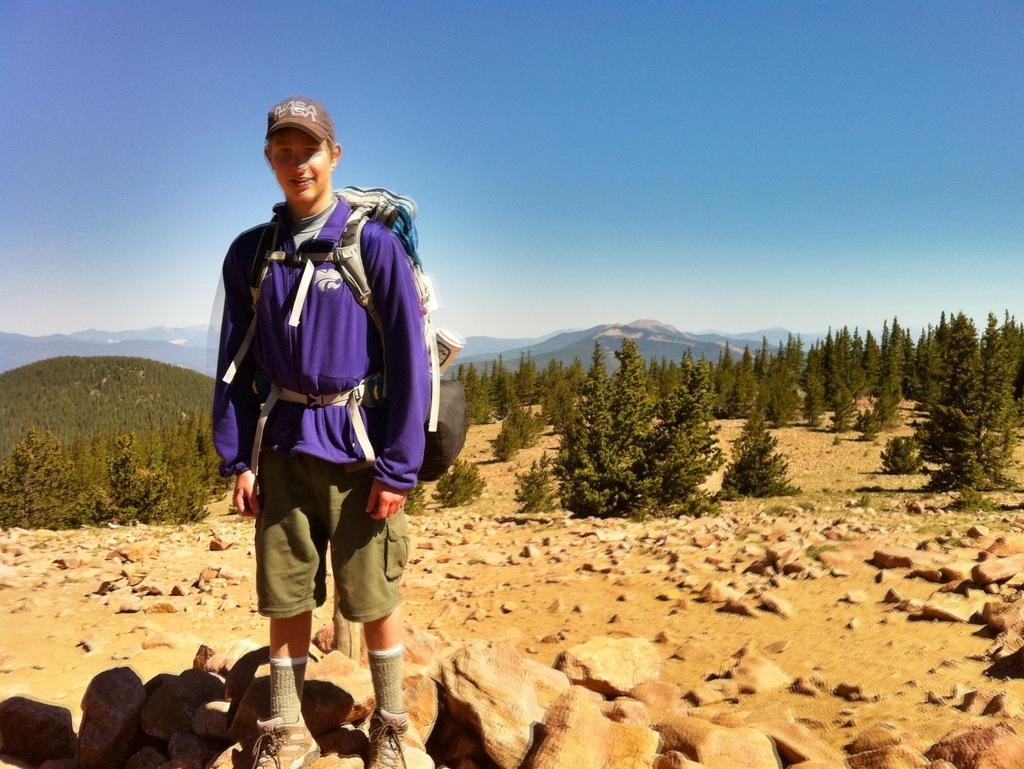Who is present in the image? There is a man in the image. What is the man wearing on his upper body? The man is wearing a blue jacket. What type of headwear is the man wearing? The man is wearing a cap. What can be seen on the ground in the image? There are stones visible in the image. What is visible in the background of the image? There are trees in the background of the image. What type of fruit is being cooked in the oven in the image? There is no oven or fruit present in the image. 